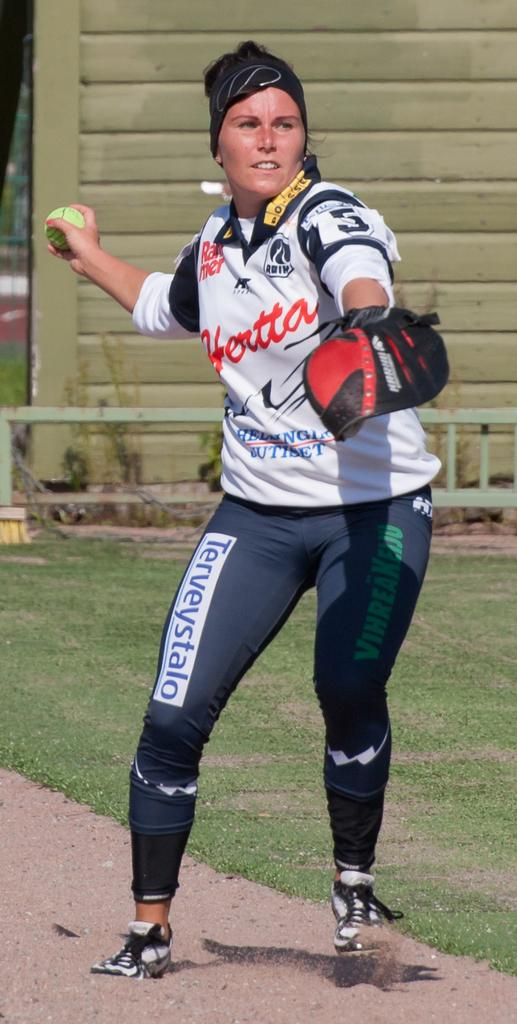<image>
Render a clear and concise summary of the photo. A woman wearing a white Hertta jersey and black pants about to throw a softball. 